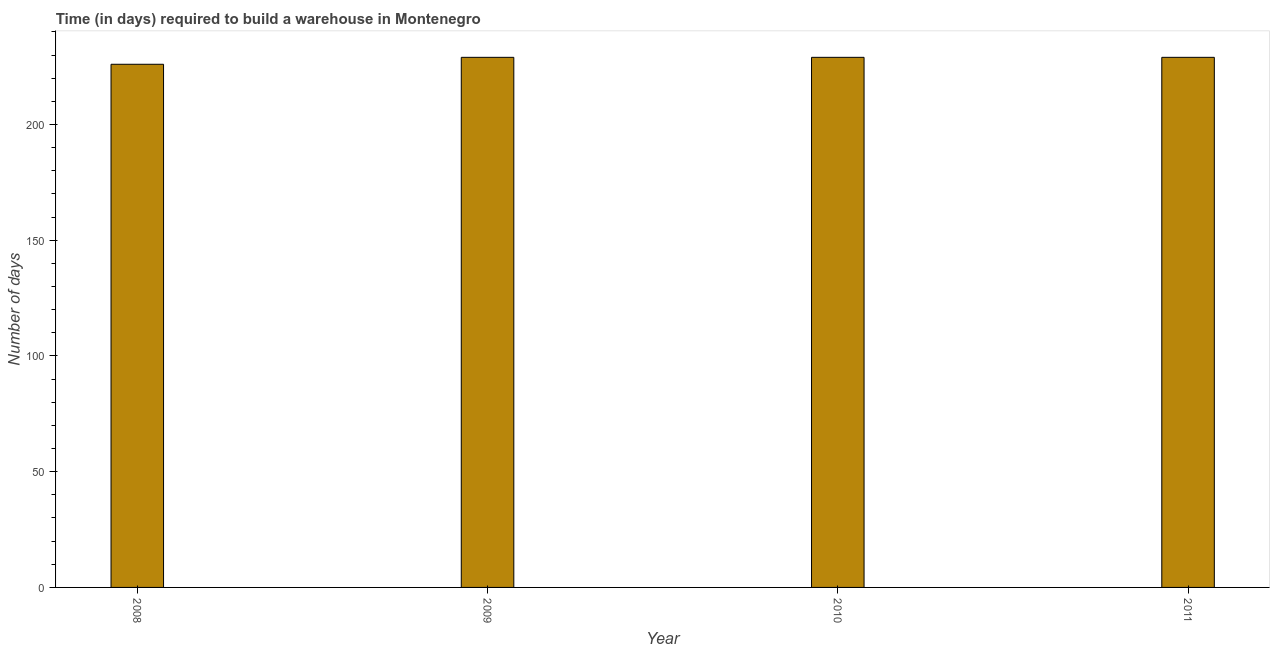Does the graph contain any zero values?
Give a very brief answer. No. Does the graph contain grids?
Provide a succinct answer. No. What is the title of the graph?
Make the answer very short. Time (in days) required to build a warehouse in Montenegro. What is the label or title of the X-axis?
Make the answer very short. Year. What is the label or title of the Y-axis?
Offer a very short reply. Number of days. What is the time required to build a warehouse in 2008?
Your response must be concise. 226. Across all years, what is the maximum time required to build a warehouse?
Give a very brief answer. 229. Across all years, what is the minimum time required to build a warehouse?
Provide a short and direct response. 226. What is the sum of the time required to build a warehouse?
Make the answer very short. 913. What is the average time required to build a warehouse per year?
Your answer should be compact. 228. What is the median time required to build a warehouse?
Provide a short and direct response. 229. Do a majority of the years between 2008 and 2010 (inclusive) have time required to build a warehouse greater than 120 days?
Provide a short and direct response. Yes. Is the sum of the time required to build a warehouse in 2009 and 2010 greater than the maximum time required to build a warehouse across all years?
Your answer should be very brief. Yes. What is the difference between the highest and the lowest time required to build a warehouse?
Provide a succinct answer. 3. In how many years, is the time required to build a warehouse greater than the average time required to build a warehouse taken over all years?
Provide a succinct answer. 3. How many bars are there?
Your response must be concise. 4. How many years are there in the graph?
Your answer should be compact. 4. What is the difference between two consecutive major ticks on the Y-axis?
Ensure brevity in your answer.  50. What is the Number of days in 2008?
Your response must be concise. 226. What is the Number of days in 2009?
Your answer should be compact. 229. What is the Number of days of 2010?
Your response must be concise. 229. What is the Number of days of 2011?
Offer a terse response. 229. What is the difference between the Number of days in 2008 and 2009?
Provide a succinct answer. -3. What is the difference between the Number of days in 2008 and 2010?
Provide a short and direct response. -3. What is the difference between the Number of days in 2008 and 2011?
Offer a very short reply. -3. What is the difference between the Number of days in 2009 and 2010?
Offer a terse response. 0. What is the difference between the Number of days in 2009 and 2011?
Offer a very short reply. 0. What is the ratio of the Number of days in 2008 to that in 2009?
Provide a short and direct response. 0.99. What is the ratio of the Number of days in 2008 to that in 2011?
Make the answer very short. 0.99. What is the ratio of the Number of days in 2009 to that in 2010?
Your answer should be compact. 1. 